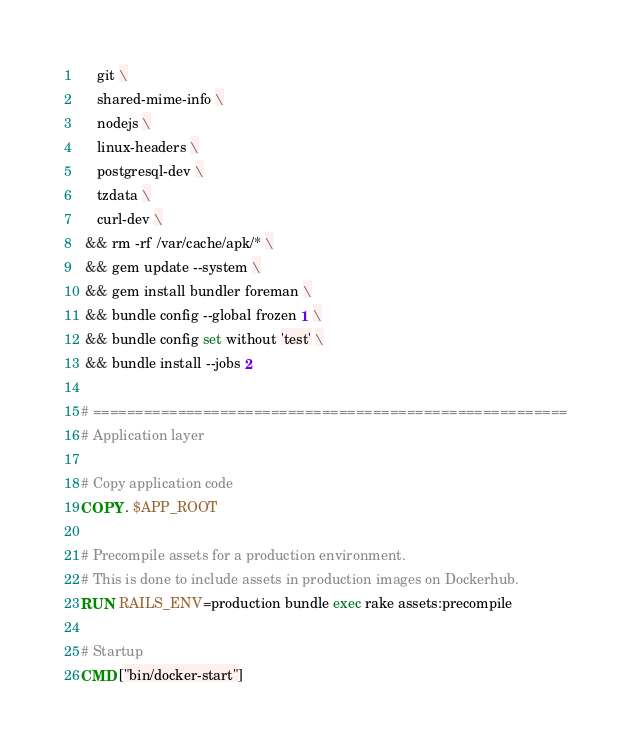Convert code to text. <code><loc_0><loc_0><loc_500><loc_500><_Dockerfile_>    git \
    shared-mime-info \
    nodejs \
    linux-headers \
    postgresql-dev \
    tzdata \
    curl-dev \
 && rm -rf /var/cache/apk/* \
 && gem update --system \
 && gem install bundler foreman \
 && bundle config --global frozen 1 \
 && bundle config set without 'test' \
 && bundle install --jobs 2

# ========================================================
# Application layer

# Copy application code
COPY . $APP_ROOT

# Precompile assets for a production environment.
# This is done to include assets in production images on Dockerhub.
RUN RAILS_ENV=production bundle exec rake assets:precompile

# Startup
CMD ["bin/docker-start"]
</code> 